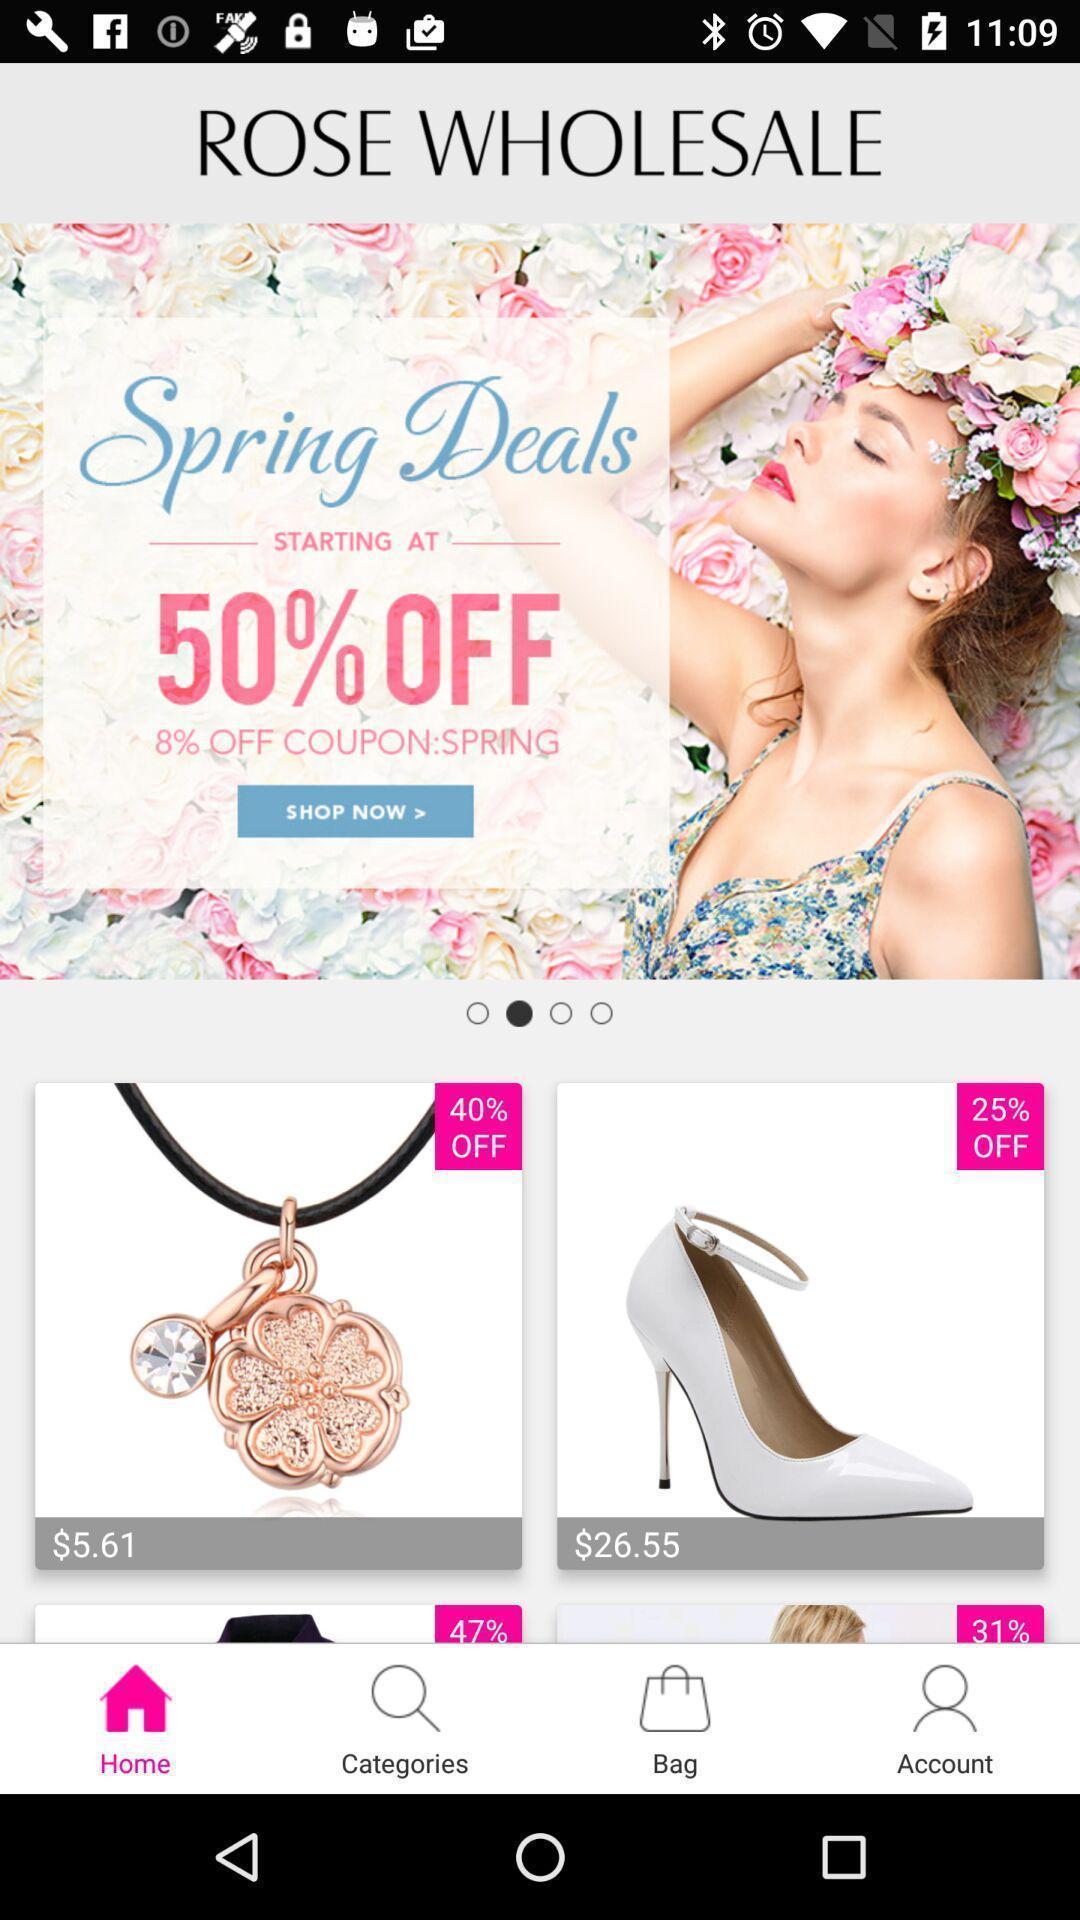What can you discern from this picture? Screen showing page of an shopping application. 